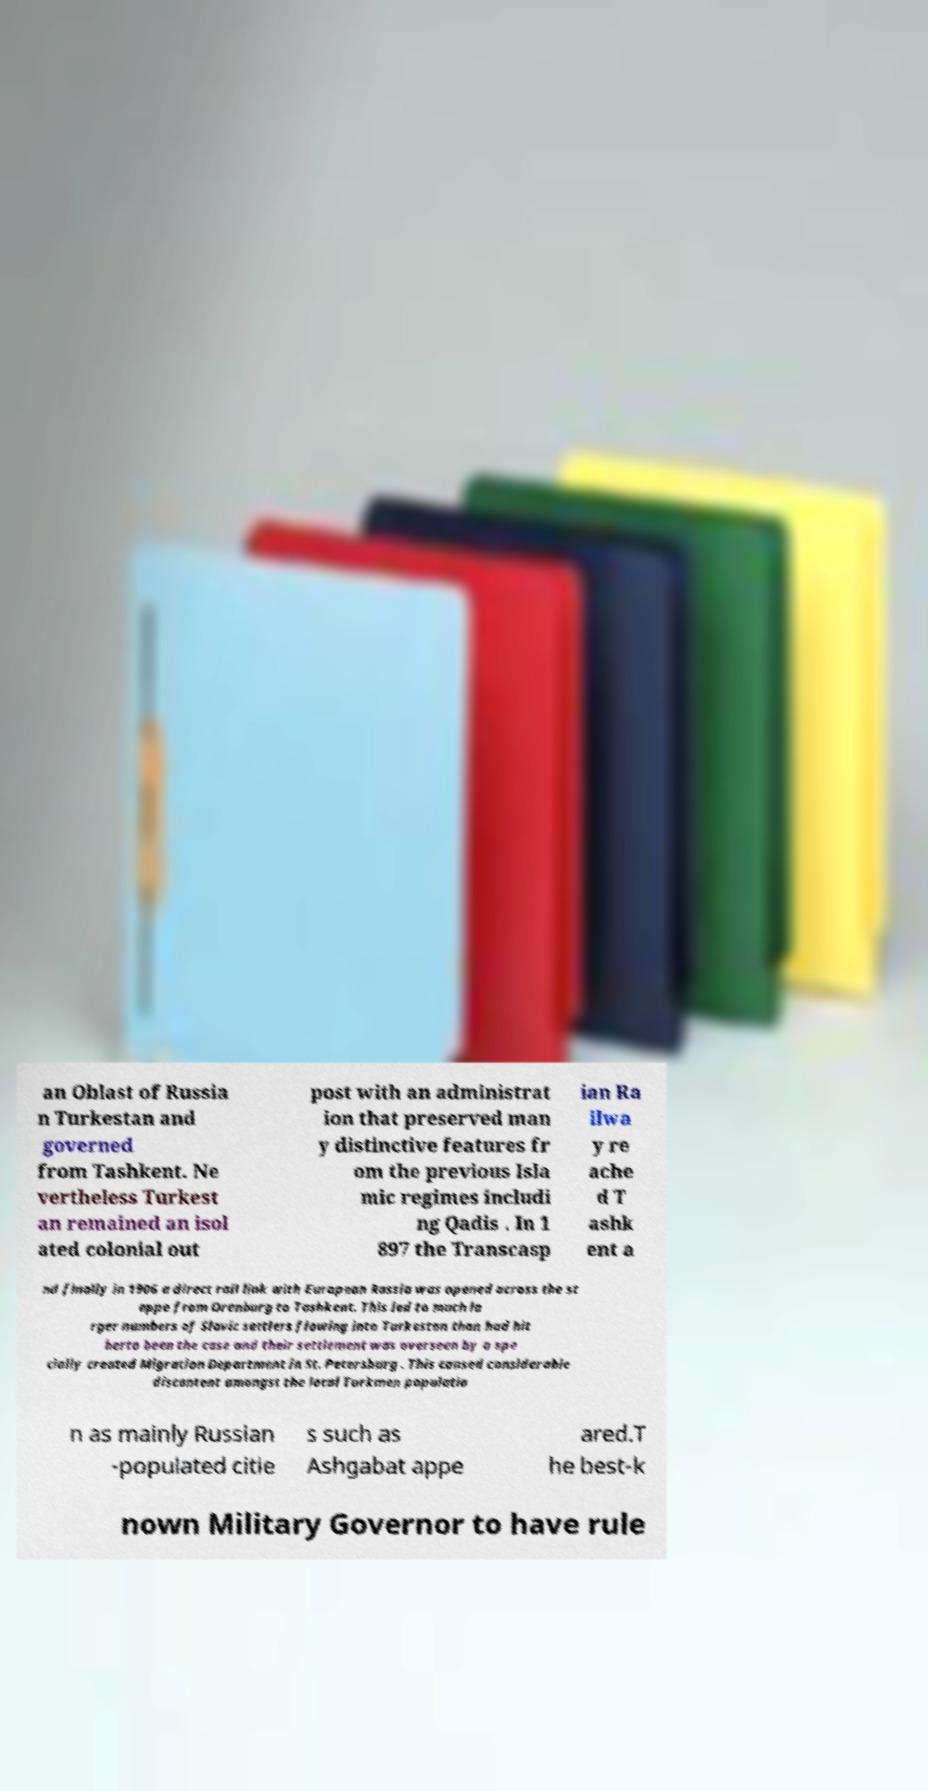For documentation purposes, I need the text within this image transcribed. Could you provide that? an Oblast of Russia n Turkestan and governed from Tashkent. Ne vertheless Turkest an remained an isol ated colonial out post with an administrat ion that preserved man y distinctive features fr om the previous Isla mic regimes includi ng Qadis . In 1 897 the Transcasp ian Ra ilwa y re ache d T ashk ent a nd finally in 1906 a direct rail link with European Russia was opened across the st eppe from Orenburg to Tashkent. This led to much la rger numbers of Slavic settlers flowing into Turkestan than had hit herto been the case and their settlement was overseen by a spe cially created Migration Department in St. Petersburg . This caused considerable discontent amongst the local Turkmen populatio n as mainly Russian -populated citie s such as Ashgabat appe ared.T he best-k nown Military Governor to have rule 